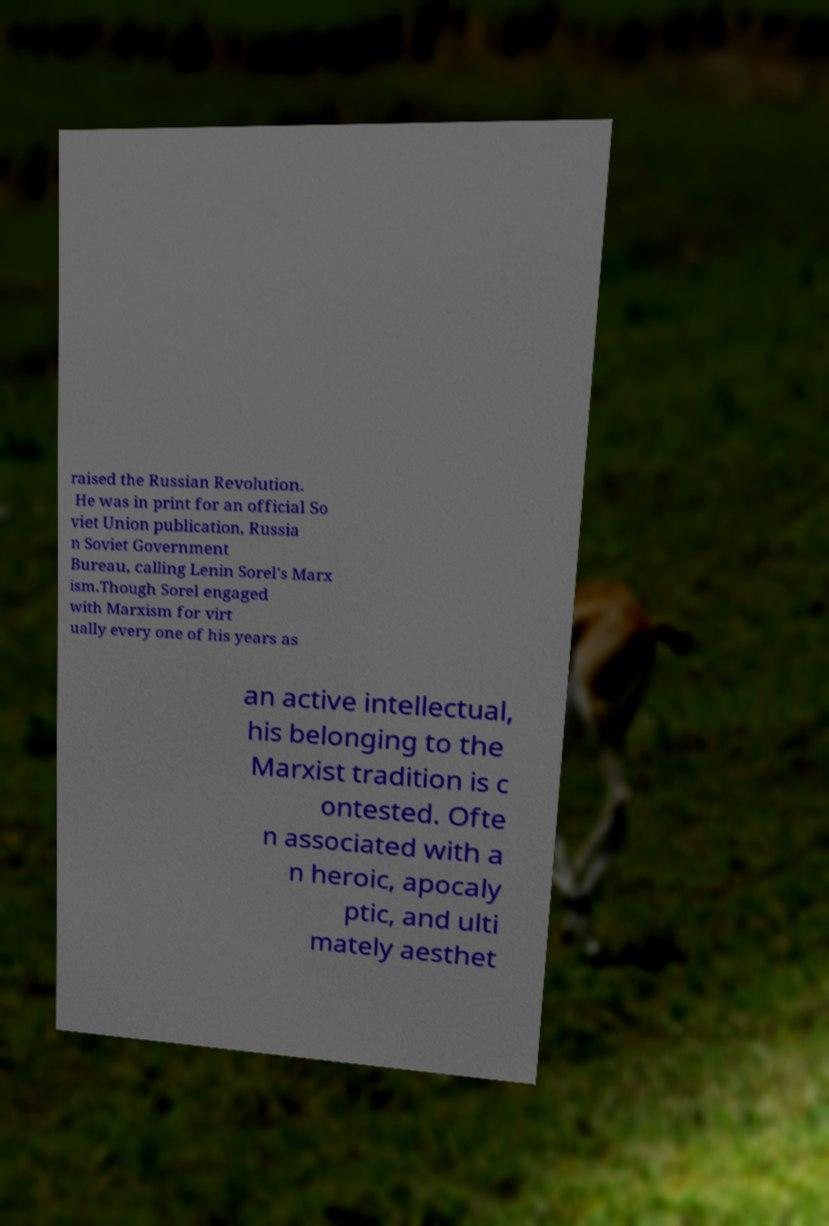I need the written content from this picture converted into text. Can you do that? raised the Russian Revolution. He was in print for an official So viet Union publication, Russia n Soviet Government Bureau, calling Lenin Sorel's Marx ism.Though Sorel engaged with Marxism for virt ually every one of his years as an active intellectual, his belonging to the Marxist tradition is c ontested. Ofte n associated with a n heroic, apocaly ptic, and ulti mately aesthet 